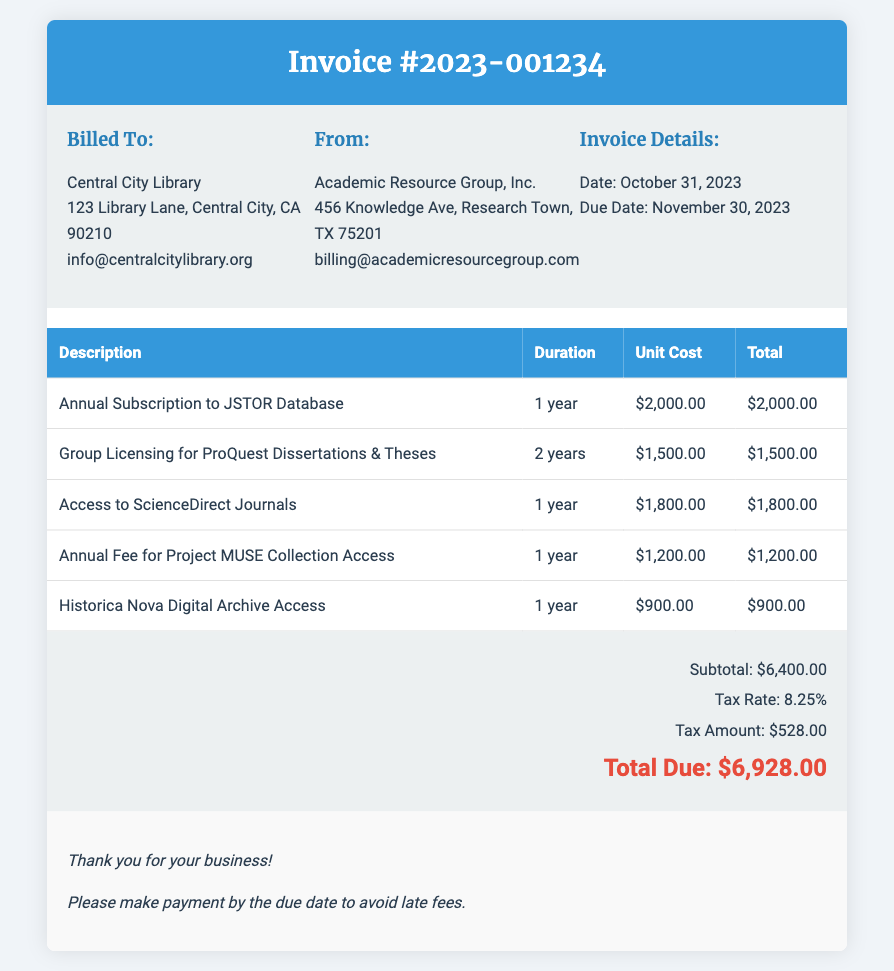What is the invoice number? The invoice number is stated at the top of the document, which identifies this specific billing.
Answer: 2023-001234 Who is billed in this invoice? The billing information in the document states the entity responsible for payment.
Answer: Central City Library What is the total due amount? The total due is provided in the invoice summary, representing the final amount to be paid including tax.
Answer: $6,928.00 What is the duration of access for JSTOR Database? The duration is listed in the table of individual items, indicating the access timeframe for each resource.
Answer: 1 year What is the tax amount on this invoice? The tax amount is calculated based on the subtotal and is included in the summary section of the document.
Answer: $528.00 How many years is the access to ProQuest Dissertations & Theses? The duration for access to this particular resource is specified in the itemized list.
Answer: 2 years What is the name of the organization providing the resources? The document lists the name of the company that issued the invoice, responsible for the resources provided.
Answer: Academic Resource Group, Inc What is the due date for payment? The due date is explicitly stated in the invoice details section, indicating when the payment must be made.
Answer: November 30, 2023 What is the unit cost for ScienceDirect Journals? The unit cost is specified in the invoice table for each resource and indicates the price per year for access.
Answer: $1,800.00 